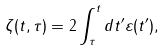Convert formula to latex. <formula><loc_0><loc_0><loc_500><loc_500>\zeta ( t , \tau ) = 2 \int _ { \tau } ^ { t } d t ^ { \prime } \varepsilon ( t ^ { \prime } ) ,</formula> 